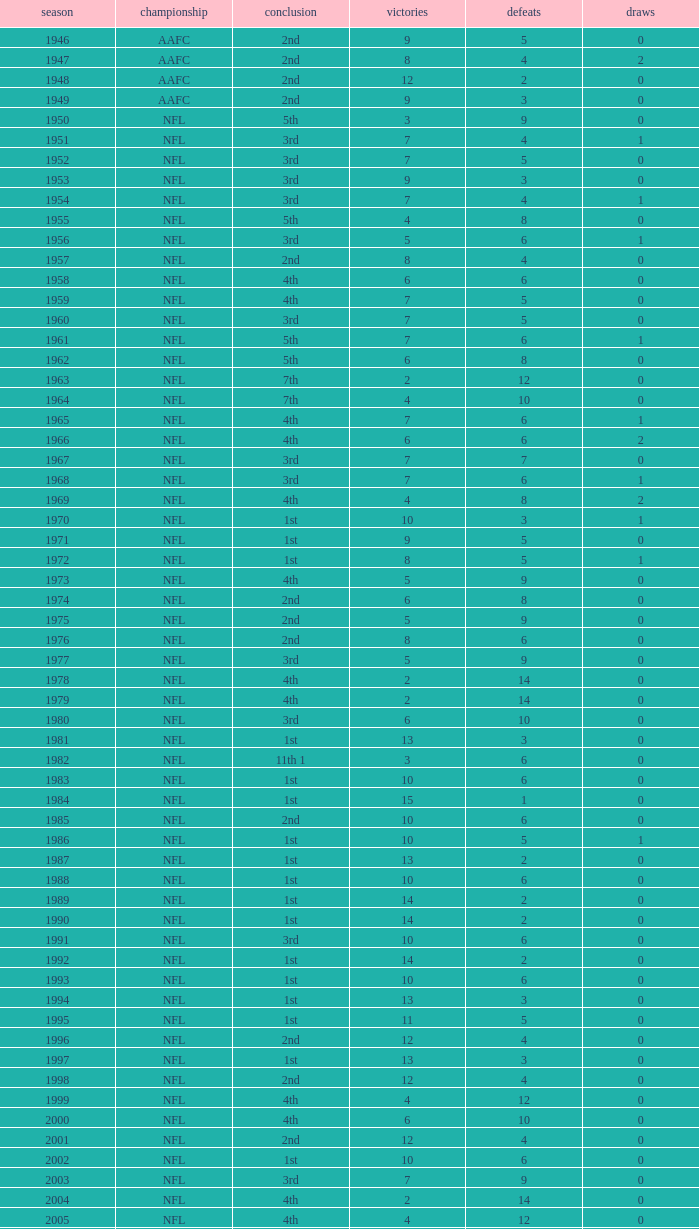What is the number of losses when the ties are lesser than 0? 0.0. 